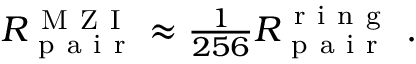<formula> <loc_0><loc_0><loc_500><loc_500>\begin{array} { r } { R _ { p a i r } ^ { M Z I } \approx \frac { 1 } { 2 5 6 } R _ { p a i r } ^ { r i n g } \ . } \end{array}</formula> 